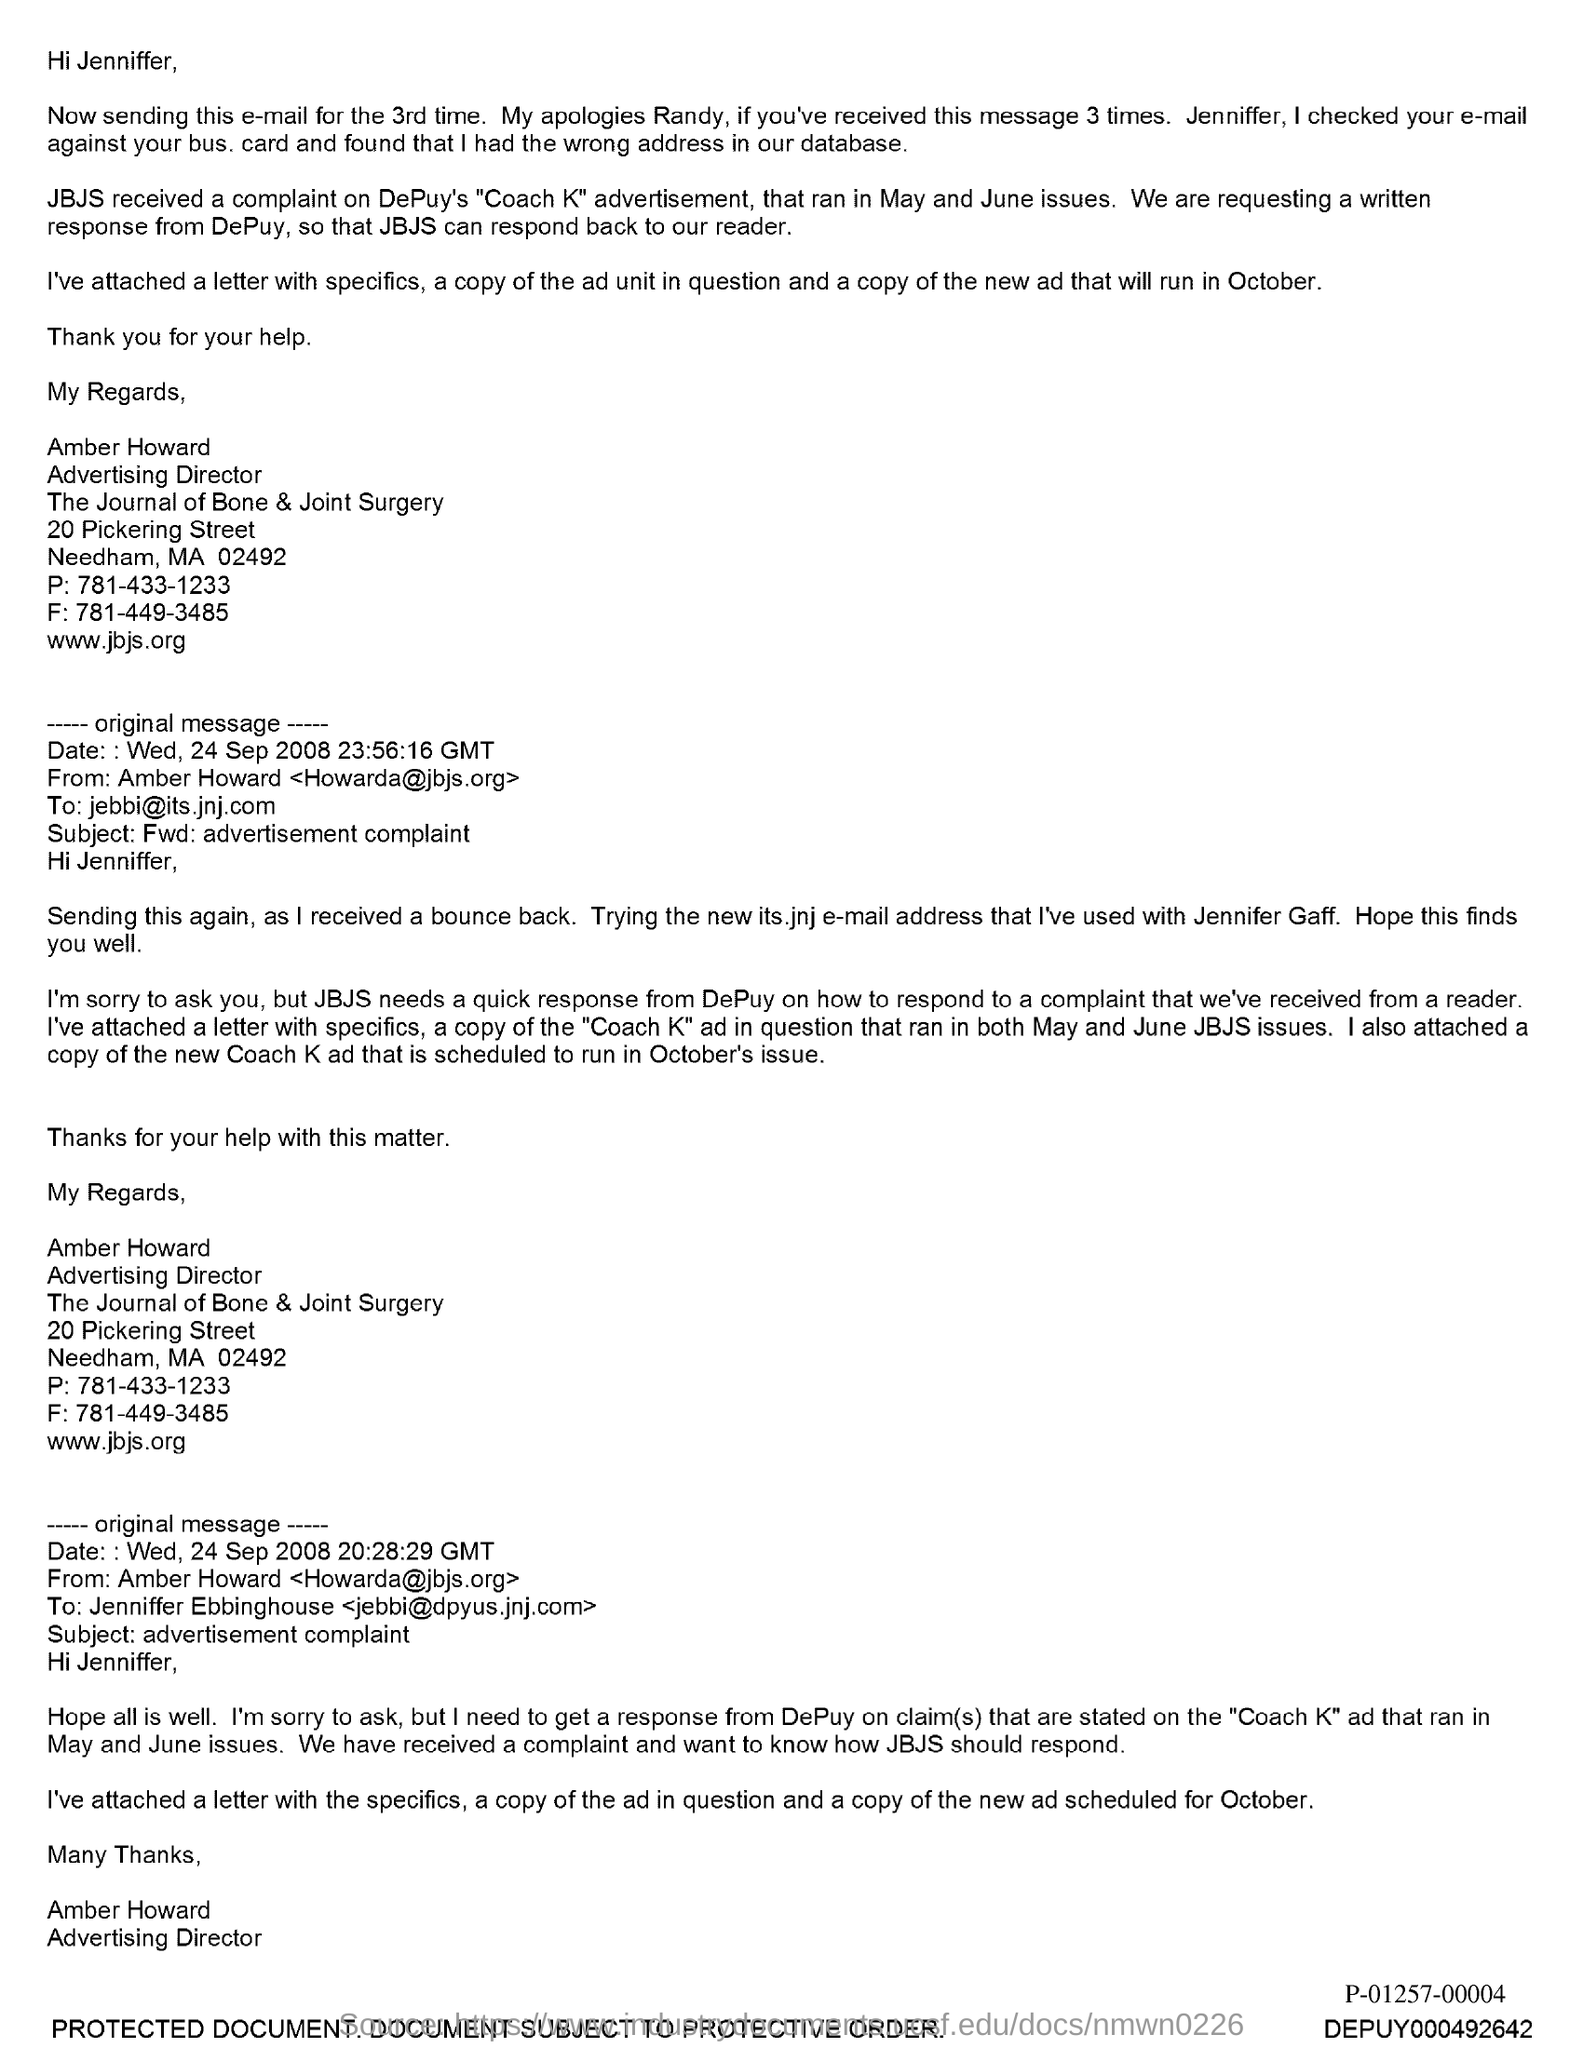What is the position of amber howard?
Your response must be concise. Advertising director. 